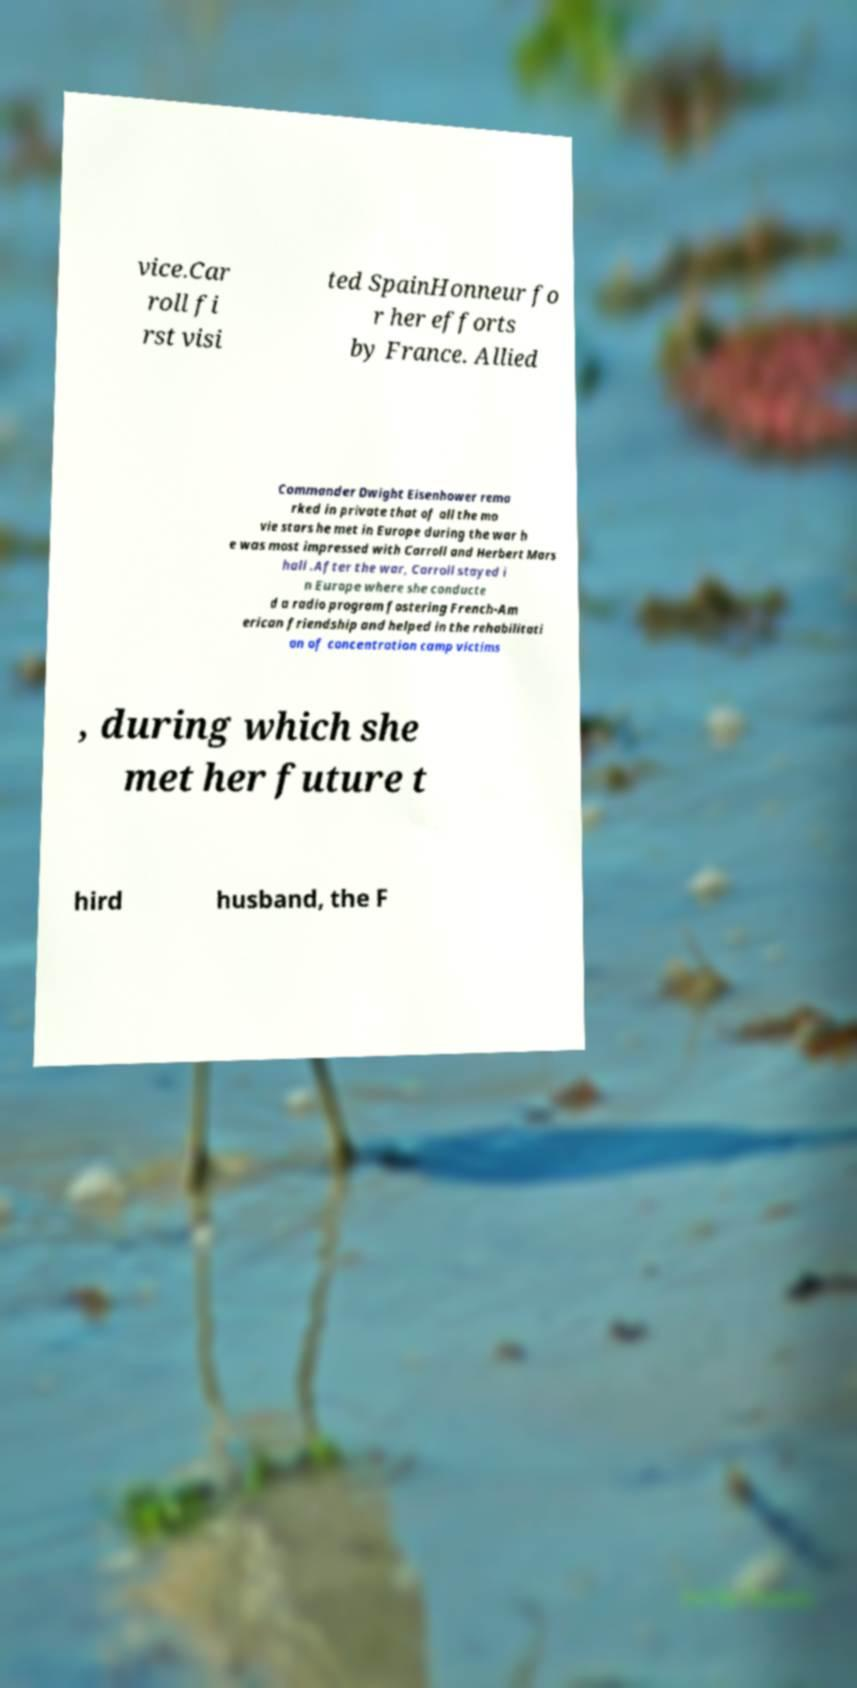Can you read and provide the text displayed in the image?This photo seems to have some interesting text. Can you extract and type it out for me? vice.Car roll fi rst visi ted SpainHonneur fo r her efforts by France. Allied Commander Dwight Eisenhower rema rked in private that of all the mo vie stars he met in Europe during the war h e was most impressed with Carroll and Herbert Mars hall .After the war, Carroll stayed i n Europe where she conducte d a radio program fostering French-Am erican friendship and helped in the rehabilitati on of concentration camp victims , during which she met her future t hird husband, the F 